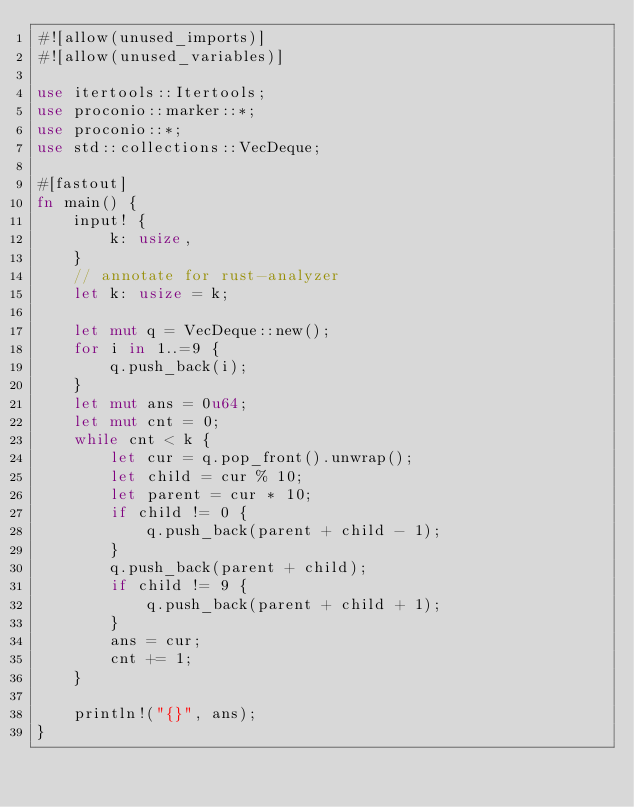Convert code to text. <code><loc_0><loc_0><loc_500><loc_500><_Rust_>#![allow(unused_imports)]
#![allow(unused_variables)]

use itertools::Itertools;
use proconio::marker::*;
use proconio::*;
use std::collections::VecDeque;

#[fastout]
fn main() {
    input! {
        k: usize,
    }
    // annotate for rust-analyzer
    let k: usize = k;

    let mut q = VecDeque::new();
    for i in 1..=9 {
        q.push_back(i);
    }
    let mut ans = 0u64;
    let mut cnt = 0;
    while cnt < k {
        let cur = q.pop_front().unwrap();
        let child = cur % 10;
        let parent = cur * 10;
        if child != 0 {
            q.push_back(parent + child - 1);
        }
        q.push_back(parent + child);
        if child != 9 {
            q.push_back(parent + child + 1);
        }
        ans = cur;
        cnt += 1;
    }

    println!("{}", ans);
}
</code> 